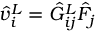Convert formula to latex. <formula><loc_0><loc_0><loc_500><loc_500>\hat { v } _ { i } ^ { L } = \hat { G } _ { i j } ^ { L } \hat { F } _ { j }</formula> 